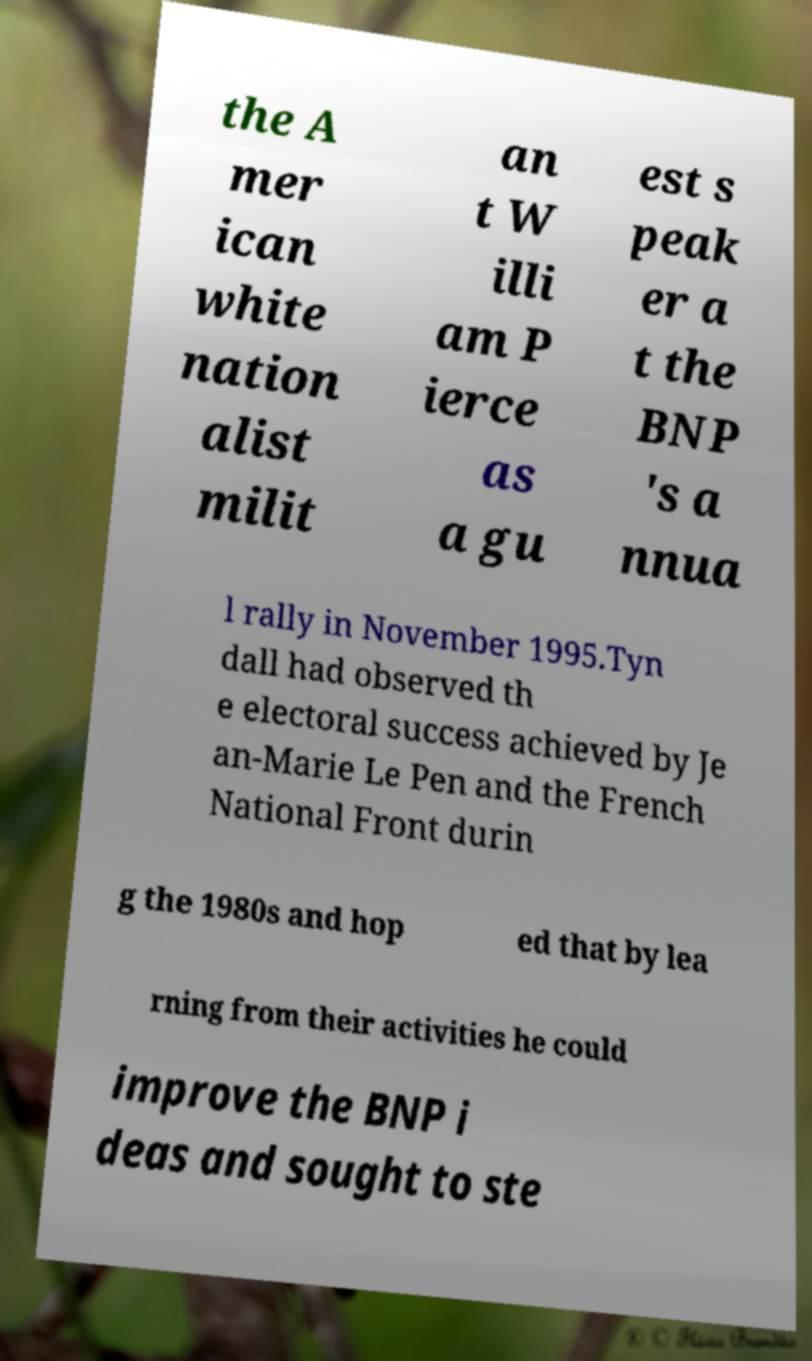Please read and relay the text visible in this image. What does it say? the A mer ican white nation alist milit an t W illi am P ierce as a gu est s peak er a t the BNP 's a nnua l rally in November 1995.Tyn dall had observed th e electoral success achieved by Je an-Marie Le Pen and the French National Front durin g the 1980s and hop ed that by lea rning from their activities he could improve the BNP i deas and sought to ste 